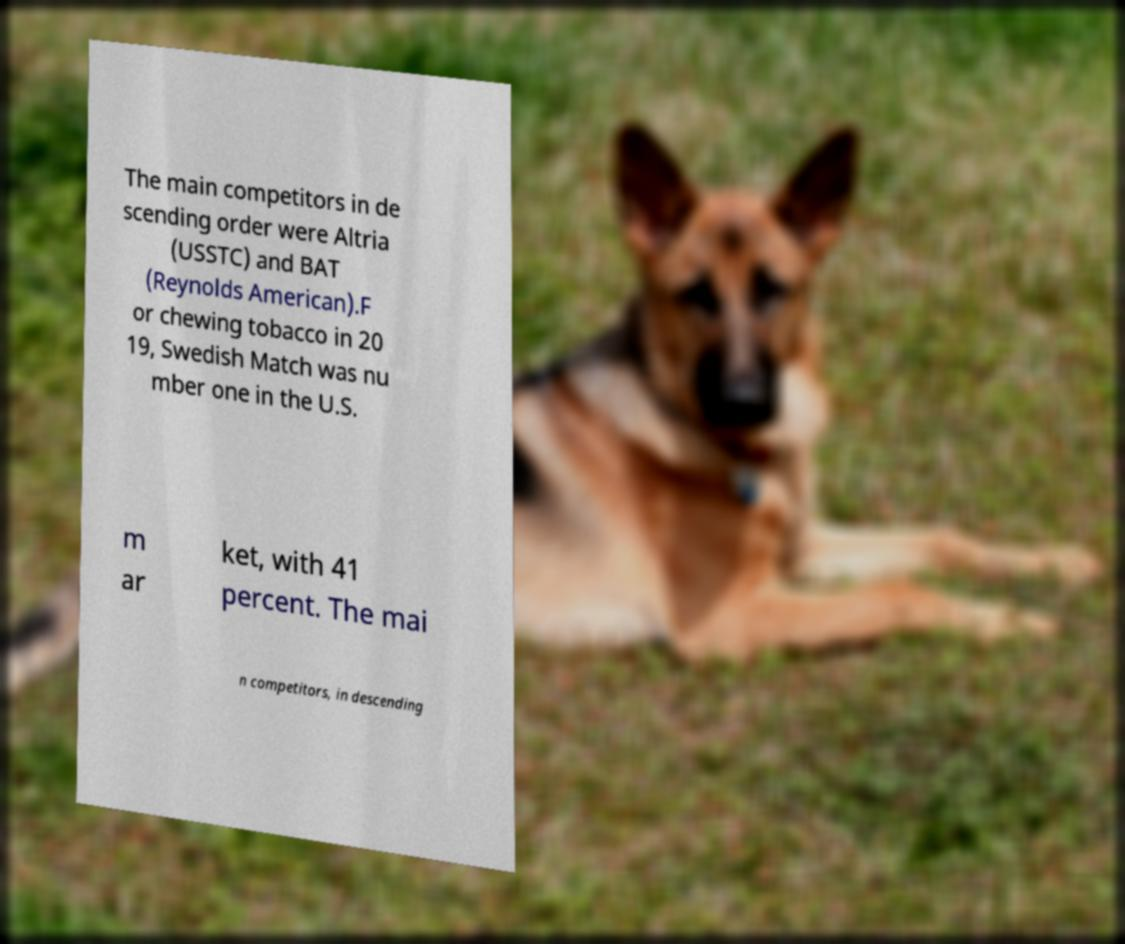Could you extract and type out the text from this image? The main competitors in de scending order were Altria (USSTC) and BAT (Reynolds American).F or chewing tobacco in 20 19, Swedish Match was nu mber one in the U.S. m ar ket, with 41 percent. The mai n competitors, in descending 